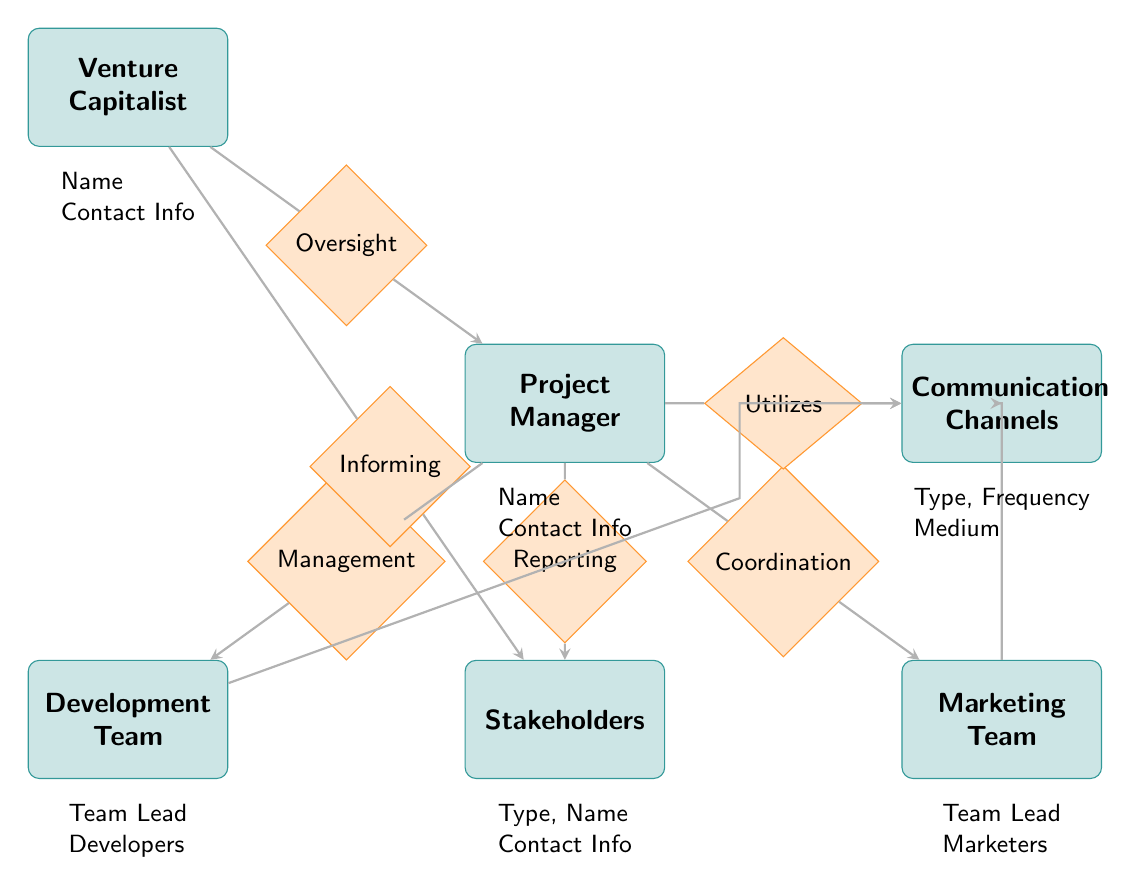What is the relationship type between the Venture Capitalist and the Project Manager? In the diagram, the relationship from the Venture Capitalist to the Project Manager is labeled as "Oversight." This indicates that the Venture Capitalist oversees the activities of the Project Manager.
Answer: Oversight How many entities are present in the diagram? By counting the labeled entities in the diagram, we find there are six entities: Venture Capitalist, Project Manager, Development Team, Marketing Team, Stakeholders, and Communication Channels.
Answer: Six Which team does the Project Manager coordinate with? The diagram indicates that the Project Manager has a relationship labeled "Coordination" with the Marketing Team, which implies that these two entities work together closely in the project.
Answer: Marketing Team What type of communication channel does the Project Manager utilize? The diagram shows a relationship where the Project Manager "Utilizes" Communication Channels. This means that the Project Manager incorporates these channels for communication purposes within the project.
Answer: Communication Channels Who is responsible for reporting to the Stakeholders? According to the diagram, the Project Manager has a relationship labeled "Reporting" with the Stakeholders. This signifies that the Project Manager is responsible for sharing updates and information with them.
Answer: Project Manager Which entity informs the Stakeholders? The Venture Capitalist has a relationship labeled "Informing" with the Stakeholders in the diagram. This indicates that the Venture Capitalist keeps the Stakeholders informed about relevant developments.
Answer: Venture Capitalist What are the two types of teams involved in the project? The diagram lists two specific teams: Development Team and Marketing Team. Both teams have distinct roles in supporting the project's objectives.
Answer: Development Team and Marketing Team Which stakeholders does the Project Manager report to? The diagram specifies that the Project Manager reports to the Stakeholders, which are categorized based on type, name, and contact information represented in the Stakeholders entity.
Answer: Stakeholders How many relationships does the Project Manager have? Upon examining the relationships connected to the Project Manager in the diagram, we find that there are four relationships: two for Management (to Development Team), Coordination (to Marketing Team), and Reporting (to Stakeholders). Hence, the total is four.
Answer: Four 